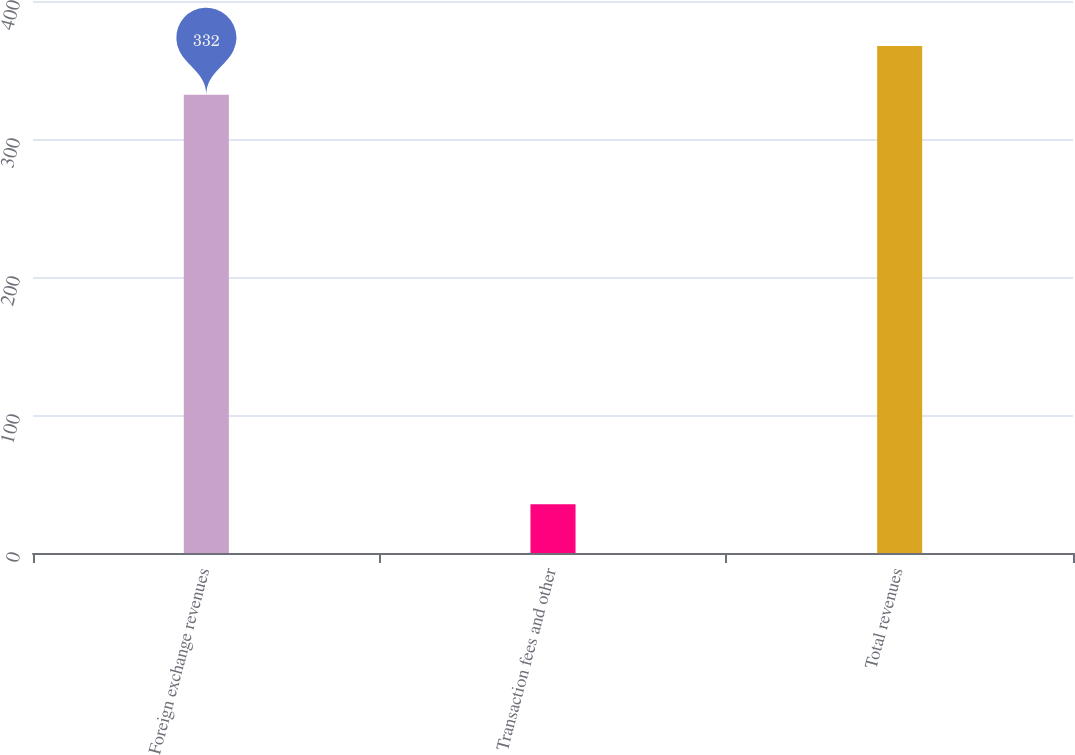Convert chart. <chart><loc_0><loc_0><loc_500><loc_500><bar_chart><fcel>Foreign exchange revenues<fcel>Transaction fees and other<fcel>Total revenues<nl><fcel>332<fcel>35.4<fcel>367.4<nl></chart> 